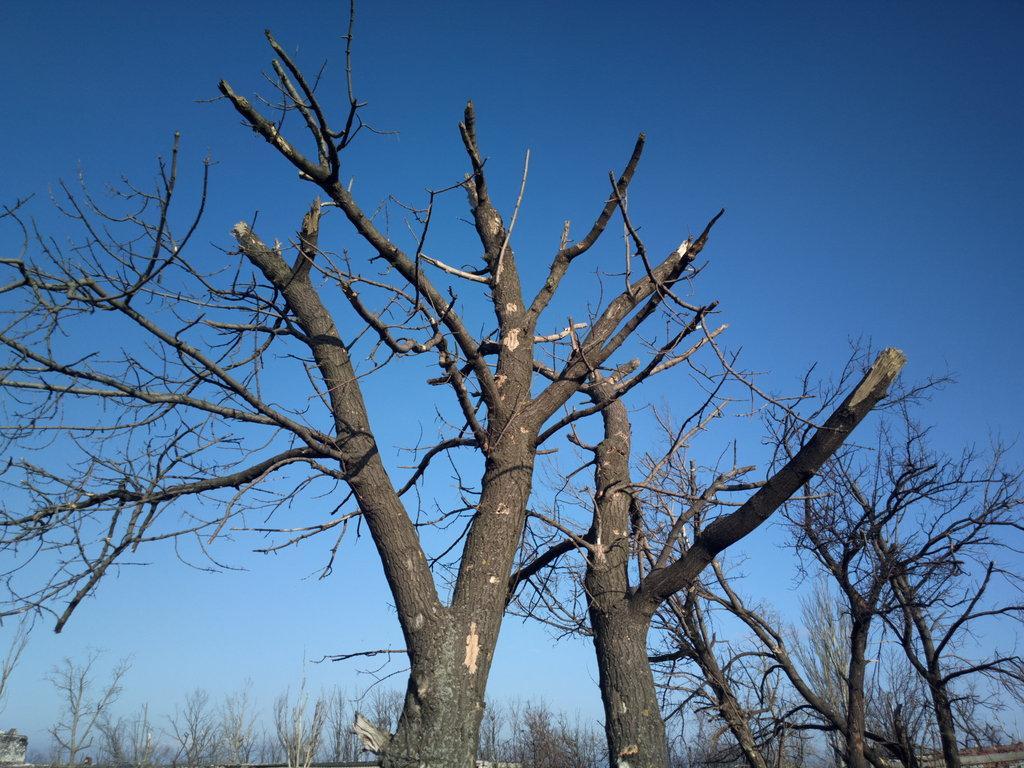Please provide a concise description of this image. In the foreground of this image, there are trees without leaves. On the top, there is the sky. 